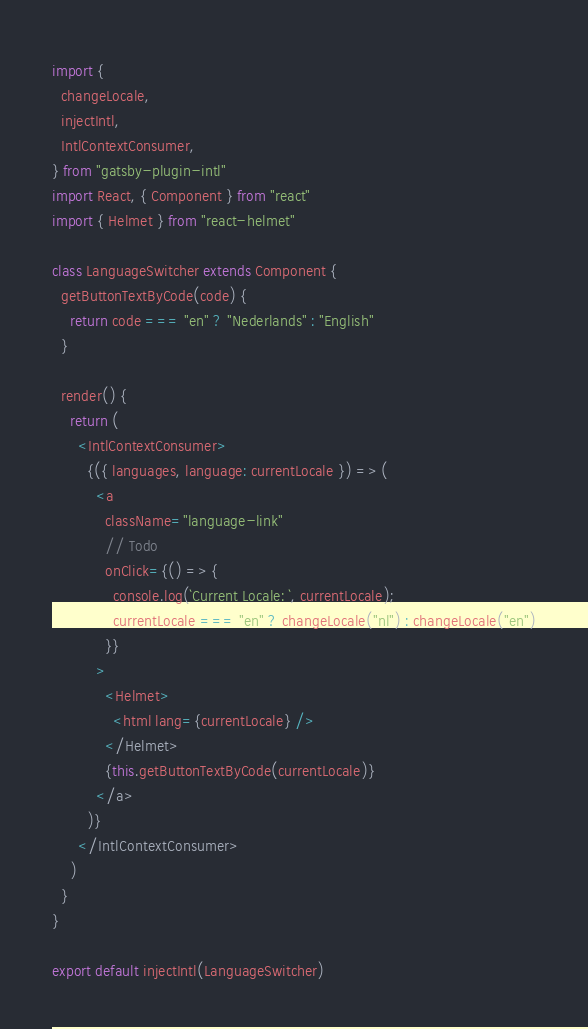<code> <loc_0><loc_0><loc_500><loc_500><_JavaScript_>import {
  changeLocale,
  injectIntl,
  IntlContextConsumer,
} from "gatsby-plugin-intl"
import React, { Component } from "react"
import { Helmet } from "react-helmet"

class LanguageSwitcher extends Component {
  getButtonTextByCode(code) {
    return code === "en" ? "Nederlands" : "English"
  }

  render() {
    return (
      <IntlContextConsumer>
        {({ languages, language: currentLocale }) => (
          <a
            className="language-link"
            // Todo
            onClick={() => {
              console.log(`Current Locale: `, currentLocale);
              currentLocale === "en" ? changeLocale("nl") : changeLocale("en")
            }}
          >
            <Helmet>
              <html lang={currentLocale} />
            </Helmet>
            {this.getButtonTextByCode(currentLocale)}
          </a>
        )}
      </IntlContextConsumer>
    )
  }
}

export default injectIntl(LanguageSwitcher)
</code> 